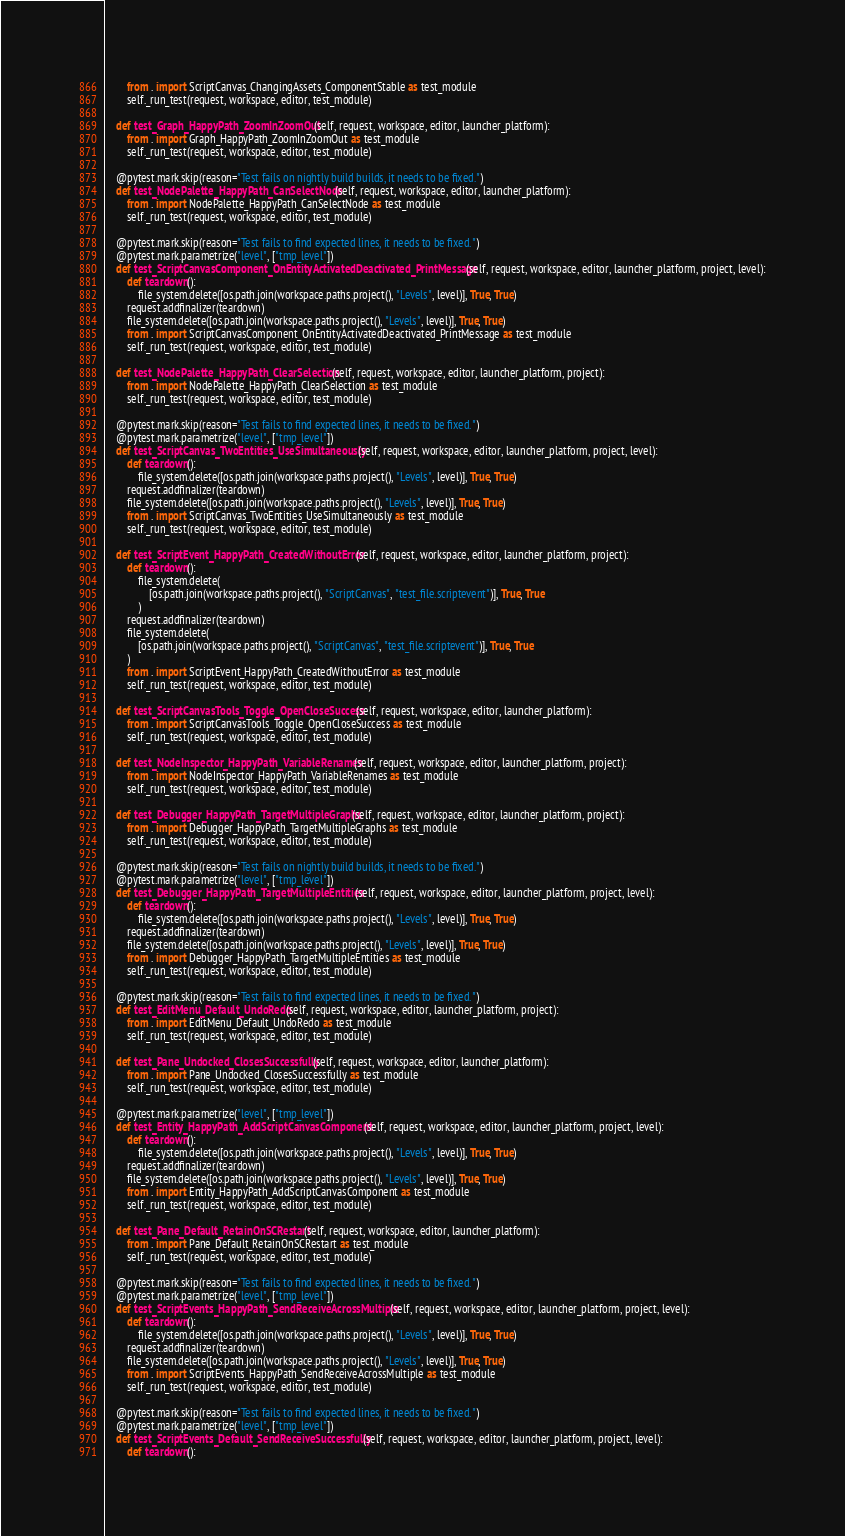Convert code to text. <code><loc_0><loc_0><loc_500><loc_500><_Python_>        from . import ScriptCanvas_ChangingAssets_ComponentStable as test_module
        self._run_test(request, workspace, editor, test_module)

    def test_Graph_HappyPath_ZoomInZoomOut(self, request, workspace, editor, launcher_platform):
        from . import Graph_HappyPath_ZoomInZoomOut as test_module
        self._run_test(request, workspace, editor, test_module)

    @pytest.mark.skip(reason="Test fails on nightly build builds, it needs to be fixed.")
    def test_NodePalette_HappyPath_CanSelectNode(self, request, workspace, editor, launcher_platform):
        from . import NodePalette_HappyPath_CanSelectNode as test_module
        self._run_test(request, workspace, editor, test_module)

    @pytest.mark.skip(reason="Test fails to find expected lines, it needs to be fixed.")
    @pytest.mark.parametrize("level", ["tmp_level"])
    def test_ScriptCanvasComponent_OnEntityActivatedDeactivated_PrintMessage(self, request, workspace, editor, launcher_platform, project, level):
        def teardown():
            file_system.delete([os.path.join(workspace.paths.project(), "Levels", level)], True, True)
        request.addfinalizer(teardown)
        file_system.delete([os.path.join(workspace.paths.project(), "Levels", level)], True, True)
        from . import ScriptCanvasComponent_OnEntityActivatedDeactivated_PrintMessage as test_module
        self._run_test(request, workspace, editor, test_module)

    def test_NodePalette_HappyPath_ClearSelection(self, request, workspace, editor, launcher_platform, project):
        from . import NodePalette_HappyPath_ClearSelection as test_module
        self._run_test(request, workspace, editor, test_module)

    @pytest.mark.skip(reason="Test fails to find expected lines, it needs to be fixed.")
    @pytest.mark.parametrize("level", ["tmp_level"])
    def test_ScriptCanvas_TwoEntities_UseSimultaneously(self, request, workspace, editor, launcher_platform, project, level):
        def teardown():
            file_system.delete([os.path.join(workspace.paths.project(), "Levels", level)], True, True)
        request.addfinalizer(teardown)
        file_system.delete([os.path.join(workspace.paths.project(), "Levels", level)], True, True)
        from . import ScriptCanvas_TwoEntities_UseSimultaneously as test_module
        self._run_test(request, workspace, editor, test_module)

    def test_ScriptEvent_HappyPath_CreatedWithoutError(self, request, workspace, editor, launcher_platform, project):
        def teardown():
            file_system.delete(
                [os.path.join(workspace.paths.project(), "ScriptCanvas", "test_file.scriptevent")], True, True
            )
        request.addfinalizer(teardown)
        file_system.delete(
            [os.path.join(workspace.paths.project(), "ScriptCanvas", "test_file.scriptevent")], True, True
        )
        from . import ScriptEvent_HappyPath_CreatedWithoutError as test_module
        self._run_test(request, workspace, editor, test_module)

    def test_ScriptCanvasTools_Toggle_OpenCloseSuccess(self, request, workspace, editor, launcher_platform):
        from . import ScriptCanvasTools_Toggle_OpenCloseSuccess as test_module
        self._run_test(request, workspace, editor, test_module)

    def test_NodeInspector_HappyPath_VariableRenames(self, request, workspace, editor, launcher_platform, project):
        from . import NodeInspector_HappyPath_VariableRenames as test_module
        self._run_test(request, workspace, editor, test_module)

    def test_Debugger_HappyPath_TargetMultipleGraphs(self, request, workspace, editor, launcher_platform, project):
        from . import Debugger_HappyPath_TargetMultipleGraphs as test_module
        self._run_test(request, workspace, editor, test_module)

    @pytest.mark.skip(reason="Test fails on nightly build builds, it needs to be fixed.")
    @pytest.mark.parametrize("level", ["tmp_level"])
    def test_Debugger_HappyPath_TargetMultipleEntities(self, request, workspace, editor, launcher_platform, project, level):
        def teardown():
            file_system.delete([os.path.join(workspace.paths.project(), "Levels", level)], True, True)
        request.addfinalizer(teardown)
        file_system.delete([os.path.join(workspace.paths.project(), "Levels", level)], True, True)
        from . import Debugger_HappyPath_TargetMultipleEntities as test_module
        self._run_test(request, workspace, editor, test_module)

    @pytest.mark.skip(reason="Test fails to find expected lines, it needs to be fixed.")
    def test_EditMenu_Default_UndoRedo(self, request, workspace, editor, launcher_platform, project):
        from . import EditMenu_Default_UndoRedo as test_module
        self._run_test(request, workspace, editor, test_module)

    def test_Pane_Undocked_ClosesSuccessfully(self, request, workspace, editor, launcher_platform):
        from . import Pane_Undocked_ClosesSuccessfully as test_module
        self._run_test(request, workspace, editor, test_module)

    @pytest.mark.parametrize("level", ["tmp_level"])
    def test_Entity_HappyPath_AddScriptCanvasComponent(self, request, workspace, editor, launcher_platform, project, level):
        def teardown():
            file_system.delete([os.path.join(workspace.paths.project(), "Levels", level)], True, True)
        request.addfinalizer(teardown)
        file_system.delete([os.path.join(workspace.paths.project(), "Levels", level)], True, True)
        from . import Entity_HappyPath_AddScriptCanvasComponent as test_module
        self._run_test(request, workspace, editor, test_module)

    def test_Pane_Default_RetainOnSCRestart(self, request, workspace, editor, launcher_platform):
        from . import Pane_Default_RetainOnSCRestart as test_module
        self._run_test(request, workspace, editor, test_module)

    @pytest.mark.skip(reason="Test fails to find expected lines, it needs to be fixed.")
    @pytest.mark.parametrize("level", ["tmp_level"])
    def test_ScriptEvents_HappyPath_SendReceiveAcrossMultiple(self, request, workspace, editor, launcher_platform, project, level):
        def teardown():
            file_system.delete([os.path.join(workspace.paths.project(), "Levels", level)], True, True)
        request.addfinalizer(teardown)
        file_system.delete([os.path.join(workspace.paths.project(), "Levels", level)], True, True)
        from . import ScriptEvents_HappyPath_SendReceiveAcrossMultiple as test_module
        self._run_test(request, workspace, editor, test_module)

    @pytest.mark.skip(reason="Test fails to find expected lines, it needs to be fixed.")
    @pytest.mark.parametrize("level", ["tmp_level"])
    def test_ScriptEvents_Default_SendReceiveSuccessfully(self, request, workspace, editor, launcher_platform, project, level):
        def teardown():</code> 